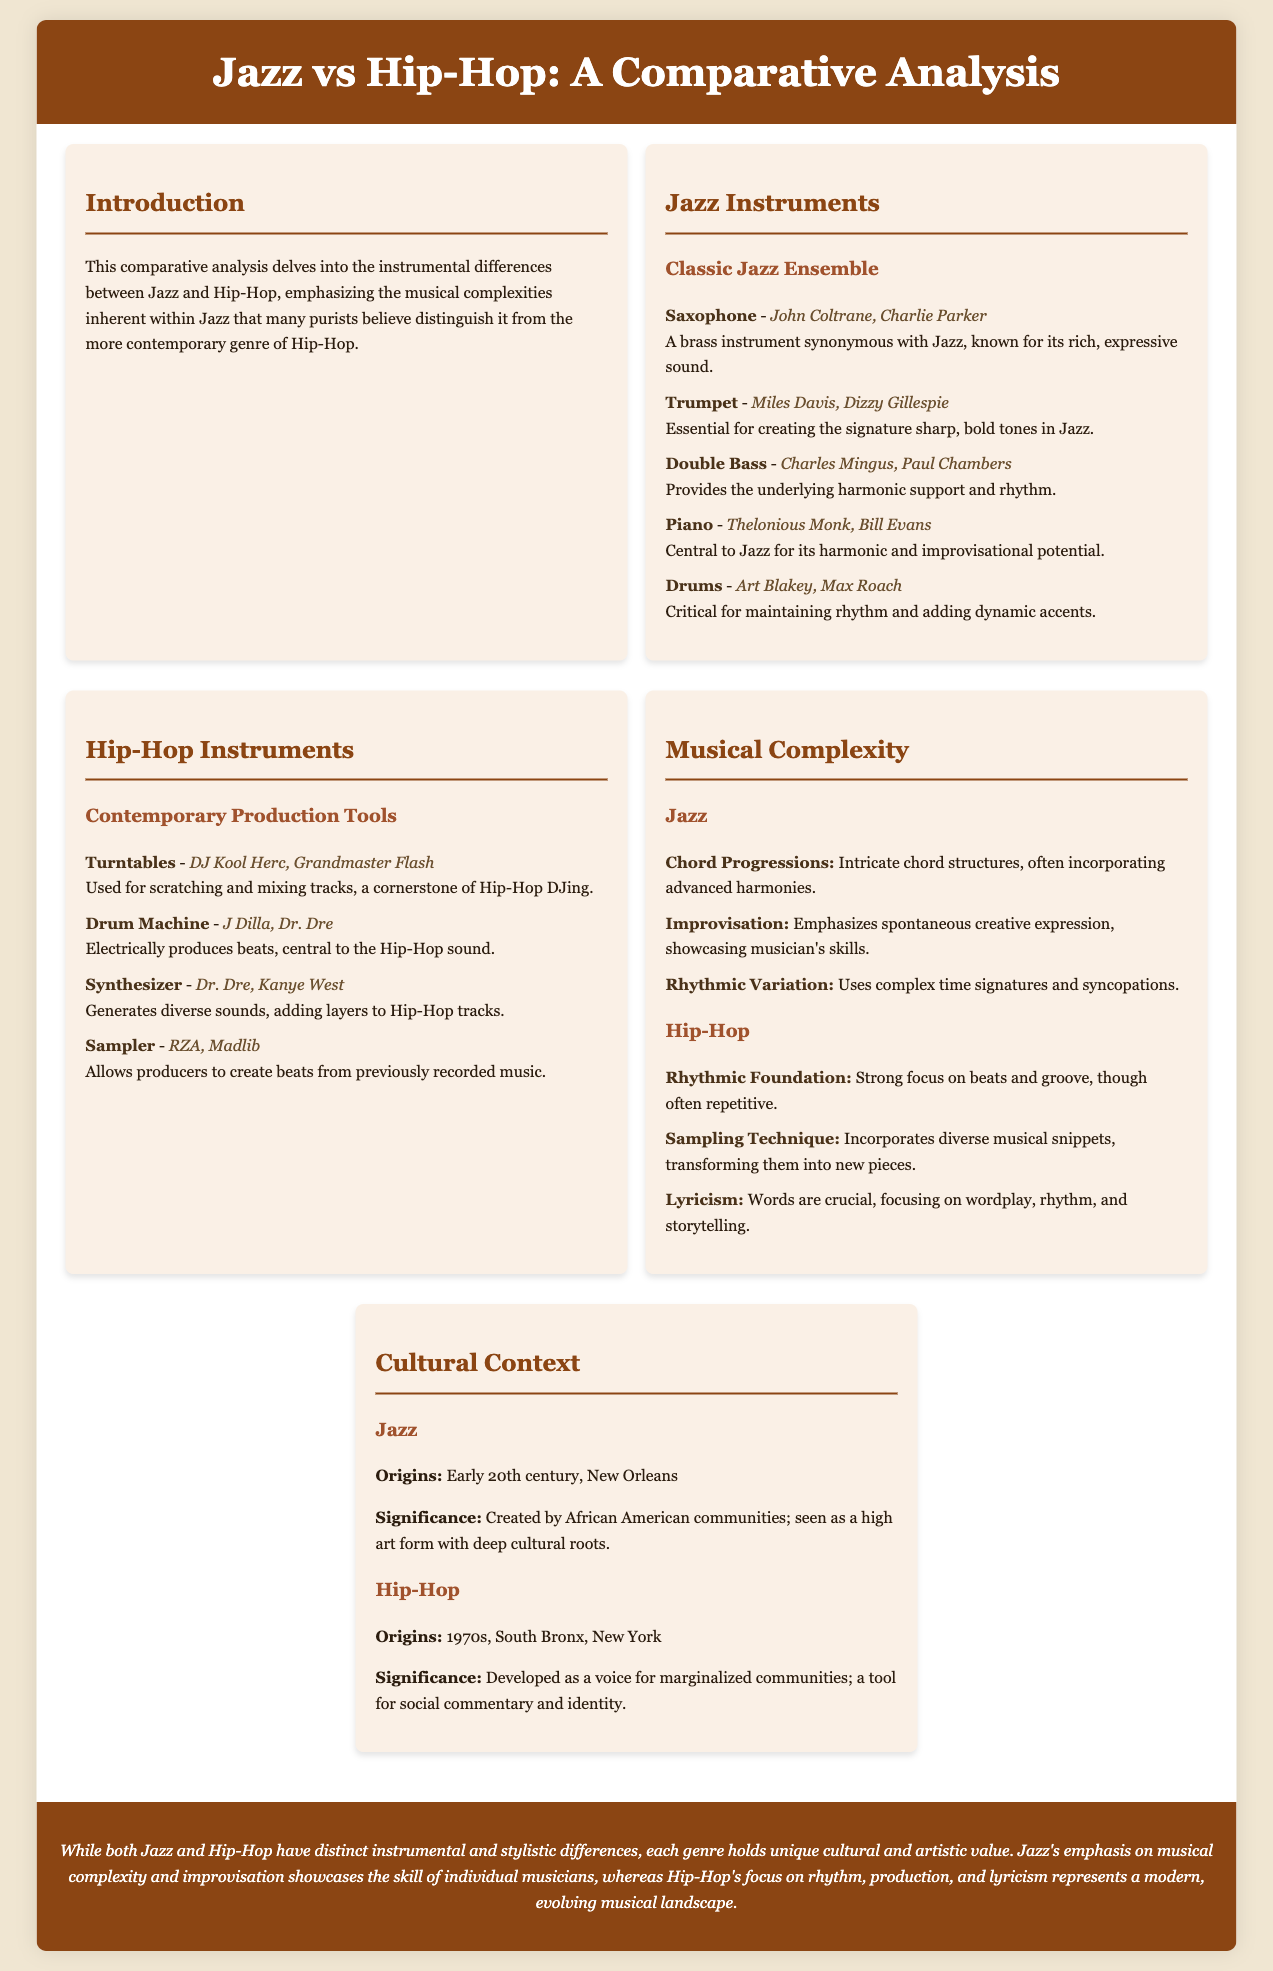what is the primary focus of the comparative analysis? The primary focus is on the instrumental differences between Jazz and Hip-Hop, highlighting musical complexities within Jazz.
Answer: instrumental differences who are two notable Jazz saxophonists mentioned? John Coltrane and Charlie Parker are both recognized saxophonists in the Jazz section.
Answer: John Coltrane, Charlie Parker what instrument is associated with J Dilla in Hip-Hop? J Dilla is prominently associated with the drum machine in the Hip-Hop section.
Answer: drum machine how many aspects of musical complexity in Jazz are listed? There are three aspects of musical complexity listed for Jazz, including chord progressions, improvisation, and rhythmic variation.
Answer: three what city is recognized as the origin of Jazz? The document states that Jazz originated in New Orleans.
Answer: New Orleans which cultural significance is attributed to Hip-Hop? Hip-Hop is noted for developing as a voice for marginalized communities and as a tool for social commentary.
Answer: voice for marginalized communities what is the main emphasis in Jazz music according to the document? The main emphasis in Jazz music is on musical complexity and improvisation.
Answer: musical complexity and improvisation how many instruments are listed under the Jazz section? Five instruments are listed in the Jazz section.
Answer: five what is the significance attributed to Jazz? Jazz is seen as a high art form with deep cultural roots, created by African American communities.
Answer: high art form with deep cultural roots 